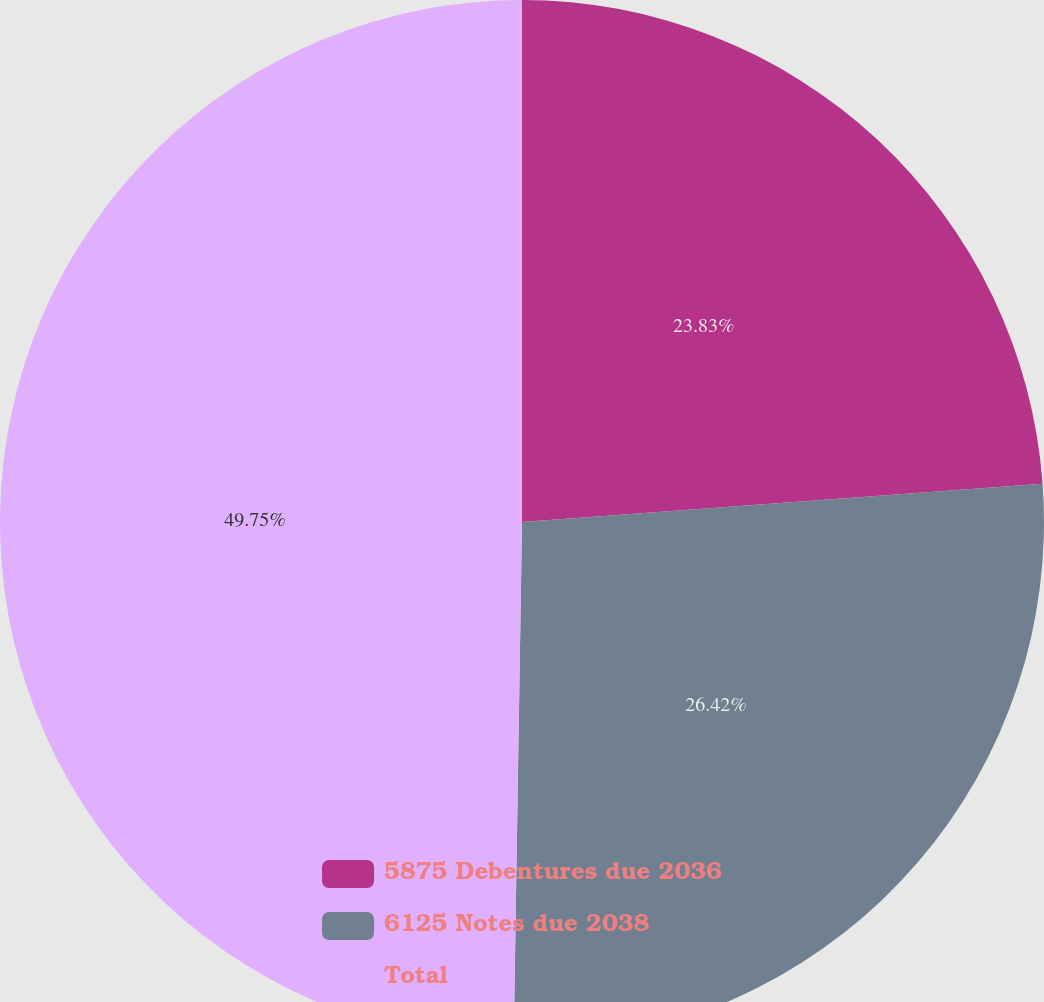<chart> <loc_0><loc_0><loc_500><loc_500><pie_chart><fcel>5875 Debentures due 2036<fcel>6125 Notes due 2038<fcel>Total<nl><fcel>23.83%<fcel>26.42%<fcel>49.74%<nl></chart> 